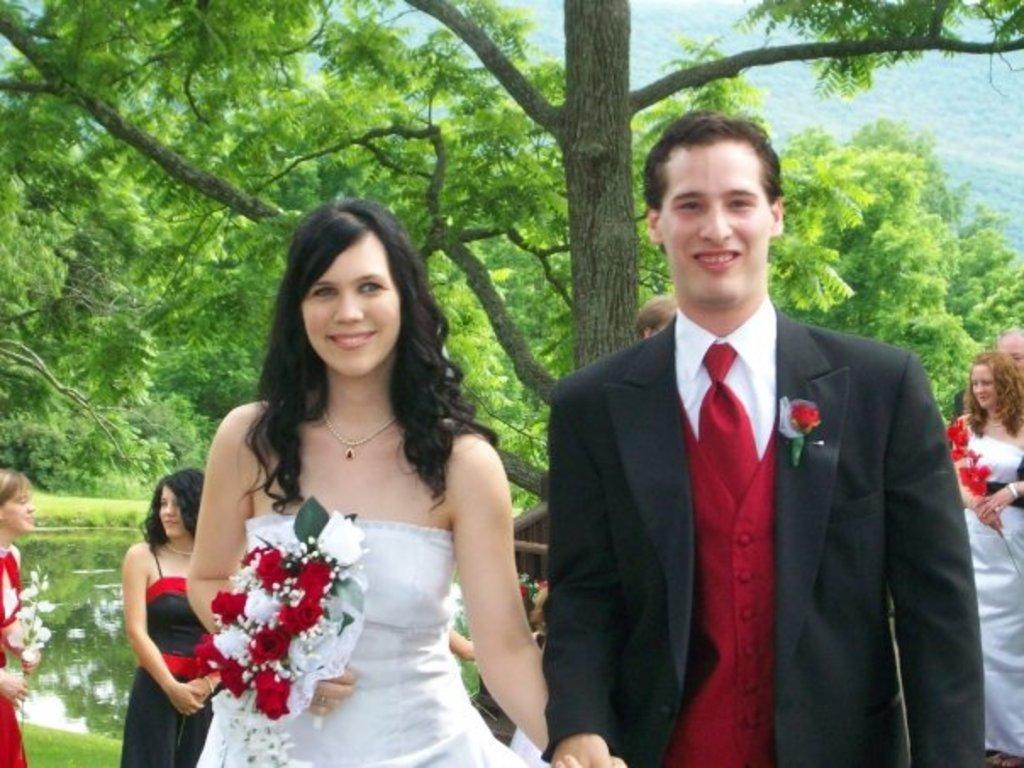Describe this image in one or two sentences. In this image we can see some people standing on the ground, some women are holding flowers in their hands. In the background, we can see the water and a group of trees. 